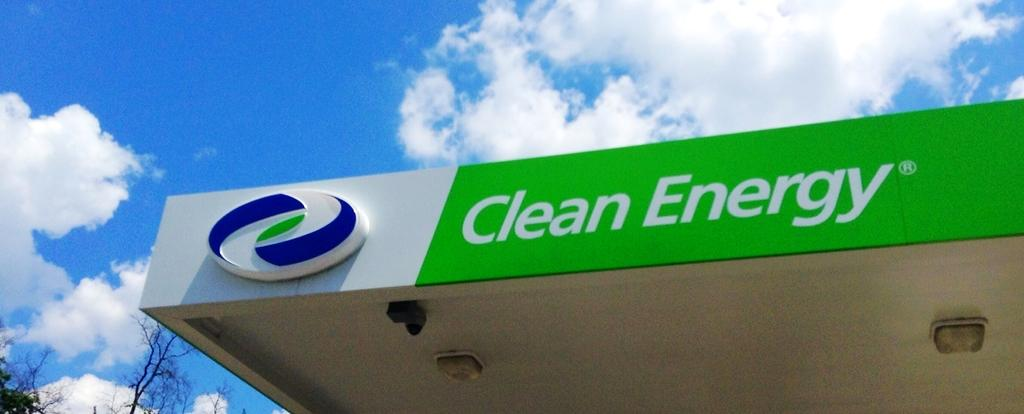Where was the picture taken? The picture was clicked outside. What is the main subject in the center of the image? There is a building with a roof in the center of the image. What is written or displayed on the roof of the building? There is text on the roof of the building. What can be seen in the background of the image? The sky and trees are visible in the background of the image. What is the condition of the sky in the image? The sky has clouds in the image. What type of hair can be seen on the egg in the image? There is no egg or hair present in the image. What activity are the children participating in during the recess in the image? There is no recess or children present in the image. 